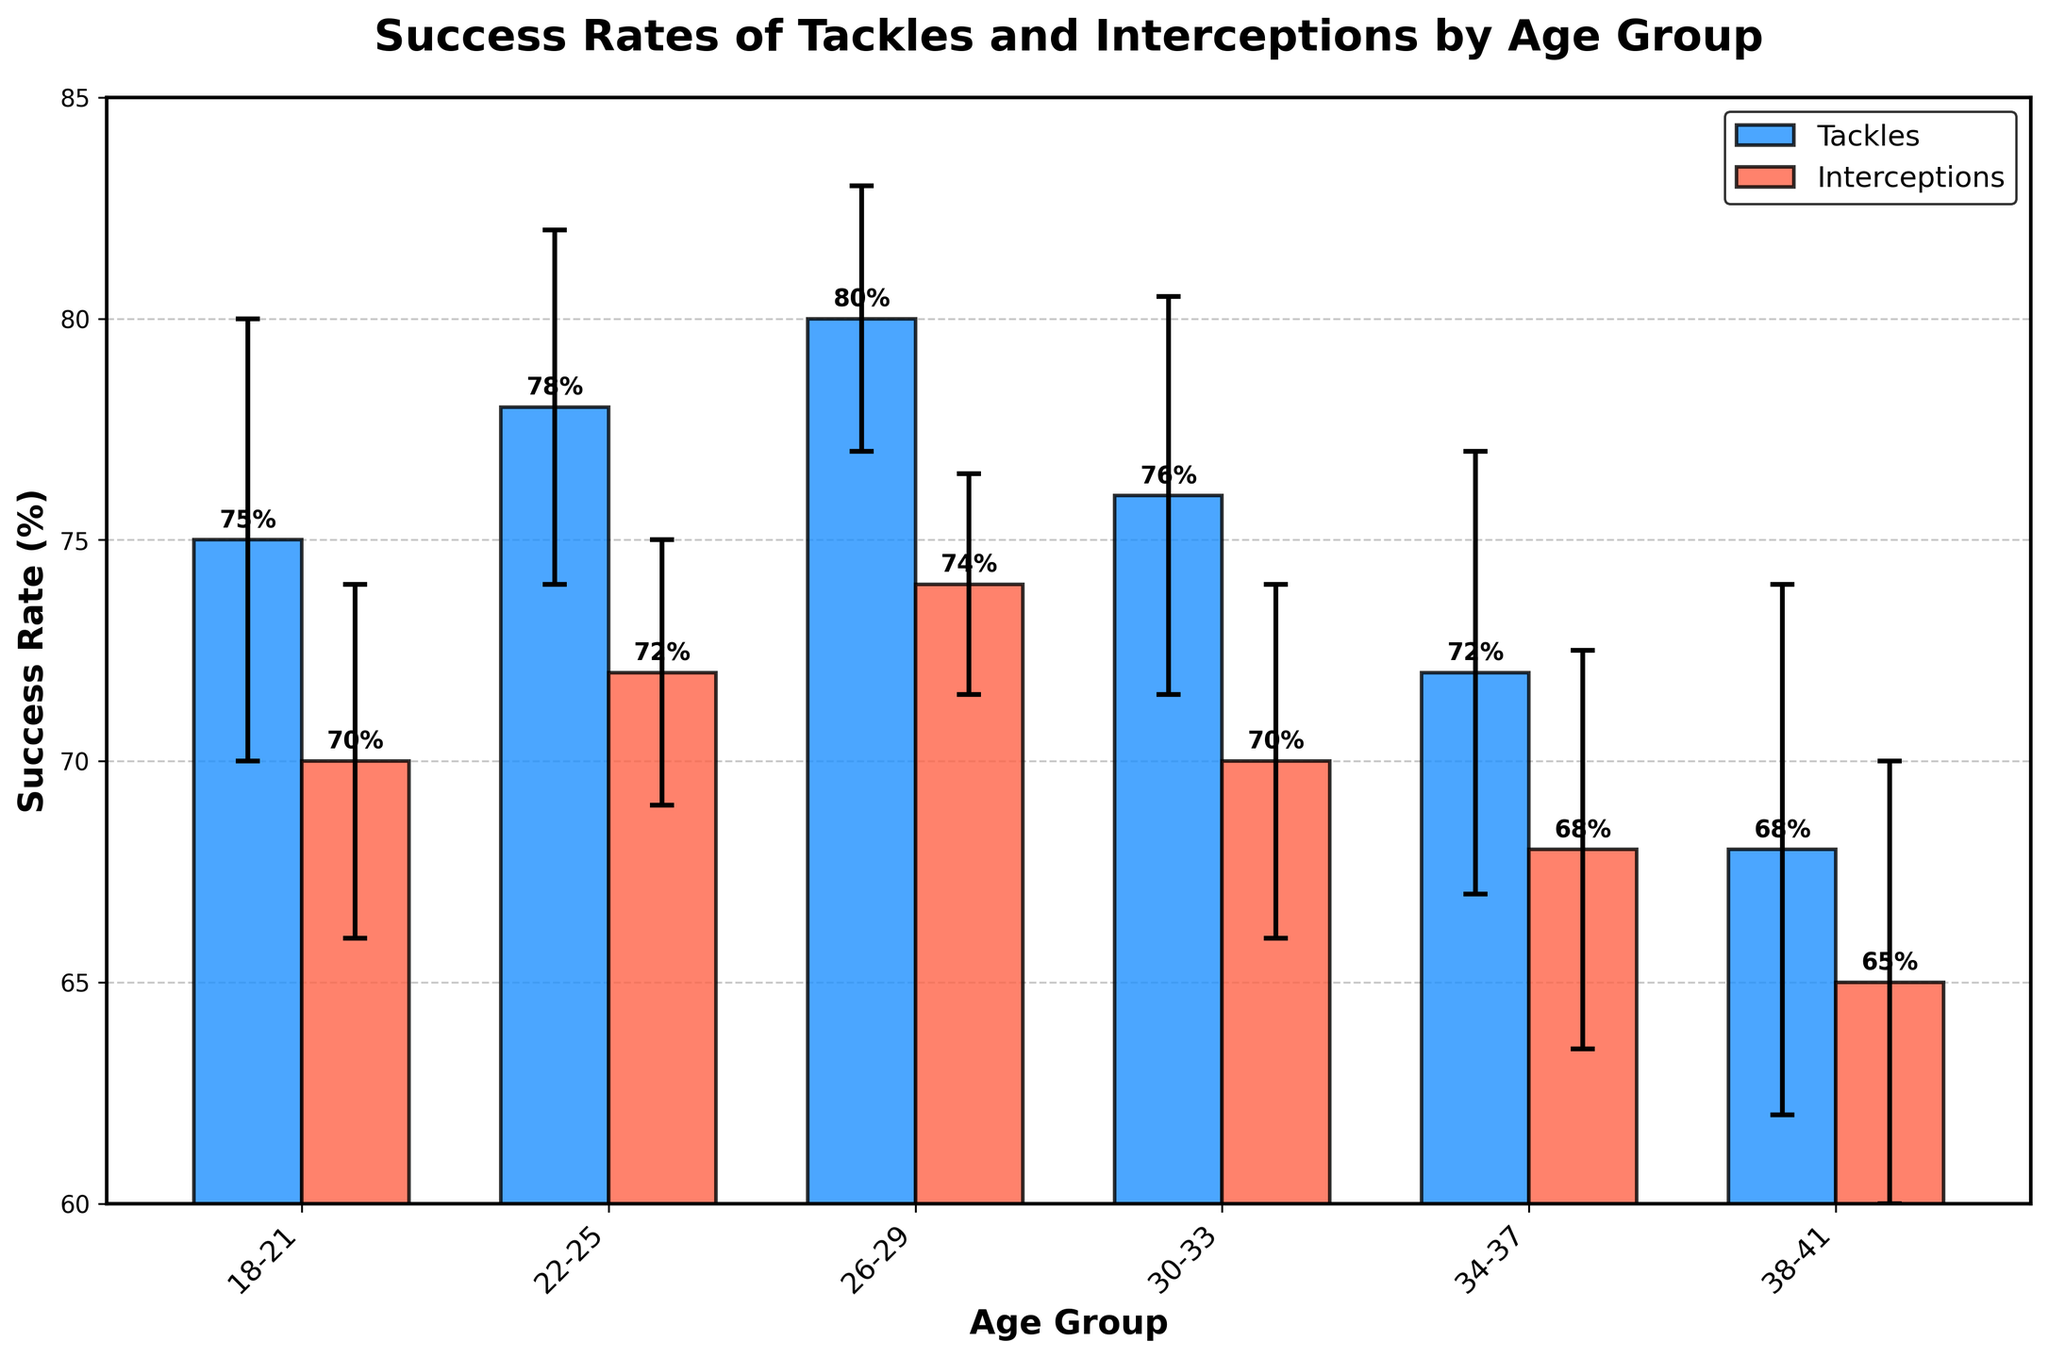What's the title of the figure? The title is displayed prominently at the top of the figure, providing a clear description of the data being visualized.
Answer: Success Rates of Tackles and Interceptions by Age Group Which age group has the highest success rate for tackles? By observing the height of the bars representing Tackles, the age group 26-29 has the tallest bar, indicating the highest success rate.
Answer: 26-29 What's the success rate of interceptions for age group 22-25? The bar corresponding to the age group 22-25 under Interceptions can be observed to determine the success rate.
Answer: 72% What's the combined success rate of tackles and interceptions for age group 34-37? Adding the values of the success rates of tackles (72) and interceptions (68) for the age group 34-37 gives the combined rate.
Answer: 140% How much does the success rate of tackles decrease from age group 26-29 to 34-37? Subtracting the success rate of tackles for 34-37 (72) from that of 26-29 (80) gives the decrease.
Answer: 8% Which age group has the largest error range for tackles? Checking the error bars for each tackles success rate, 38-41 has the largest range (6).
Answer: 38-41 What's the difference in interceptions success rate between age groups 18-21 and 30-33? Subtracting 70 (18-21) from 70 (30-33) shows the difference.
Answer: 0% In which age group is the gap between success rates of tackles and interceptions the smallest? For age group 30-33, the gap between 76 (tackles) and 70 (interceptions) is 6, which is the smallest among all age groups.
Answer: 30-33 What is the average success rate of tackles across all age groups? Adding the tackle rates: (75 + 78 + 80 + 76 + 72 + 68) and dividing by 6 gives the average. Calculation: 449 / 6 ≈ 74.83.
Answer: ~74.83% Compare the error range for interceptions between age group 22-25 and 38-41. The error bar for interceptions in 22-25 is 3, whereas for 38-41 it is 5, indicating 38-41 has a larger error range.
Answer: 38-41 has a larger error range 